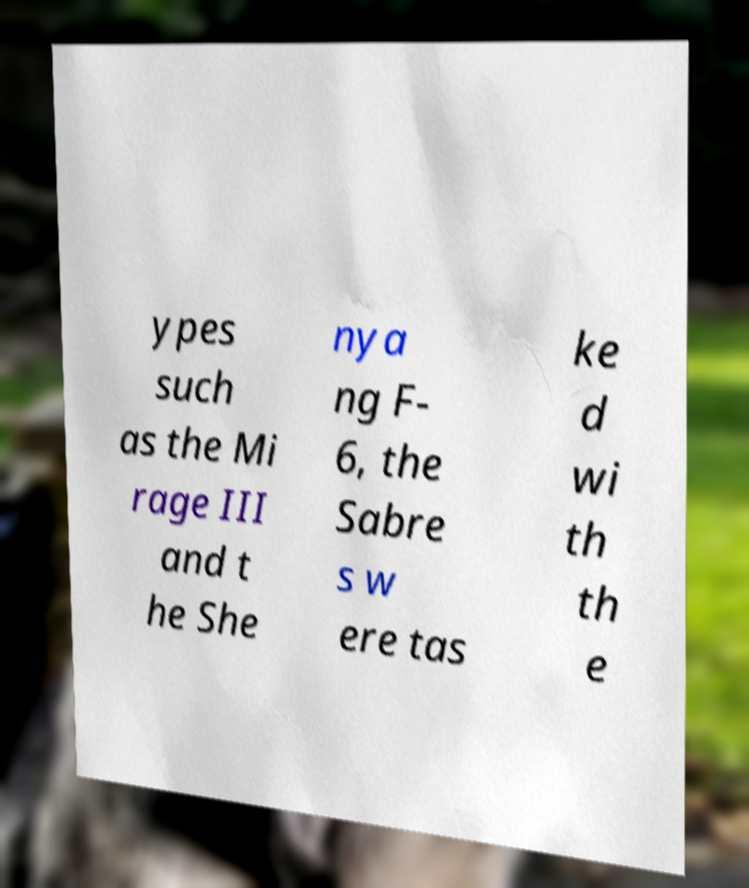Please identify and transcribe the text found in this image. ypes such as the Mi rage III and t he She nya ng F- 6, the Sabre s w ere tas ke d wi th th e 